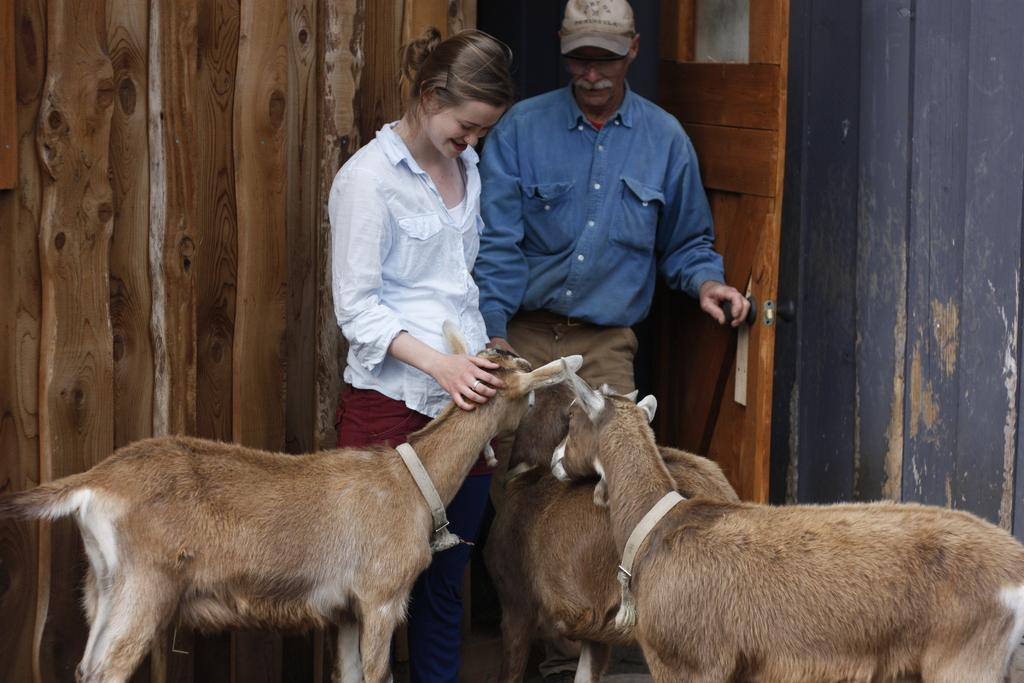How many people are present in the image? There are two people, a man and a woman, present in the image. What are the people in the image doing? Both the man and woman are standing and smiling. What else can be seen in the image besides the people? There are animals, caps, a door, and walls in the image. How does the man skate in the image? There is no indication in the image that the man is skating; he is standing and smiling. 